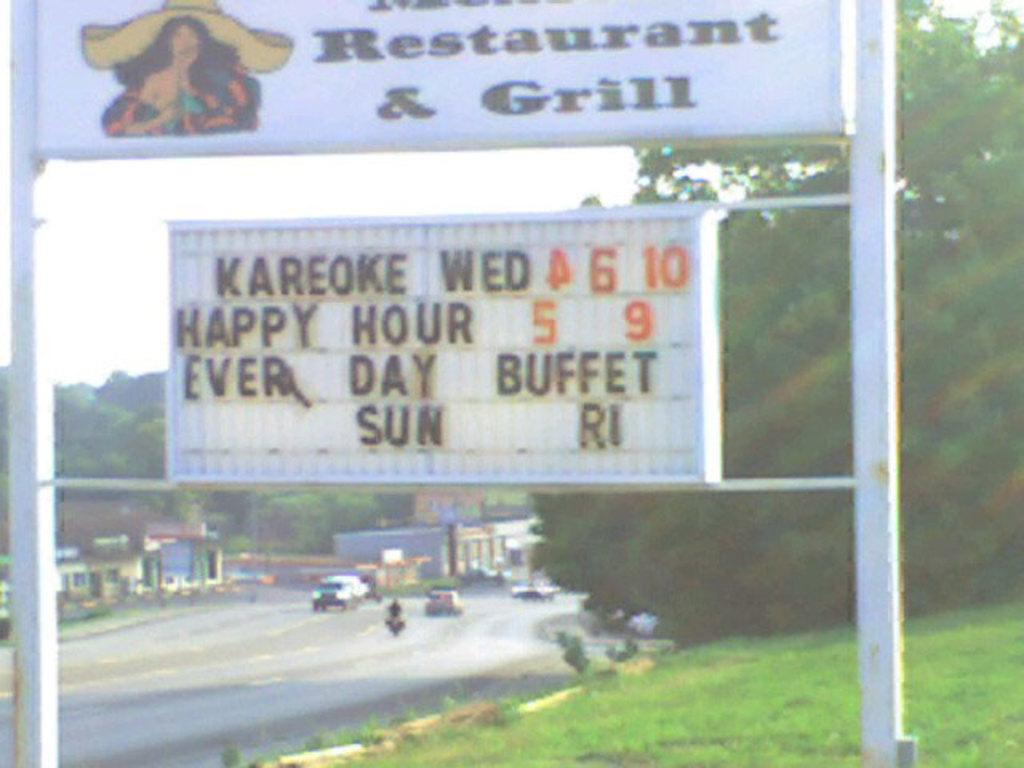<image>
Render a clear and concise summary of the photo. Restaurant and grill that includes a karoke and every day buffet 